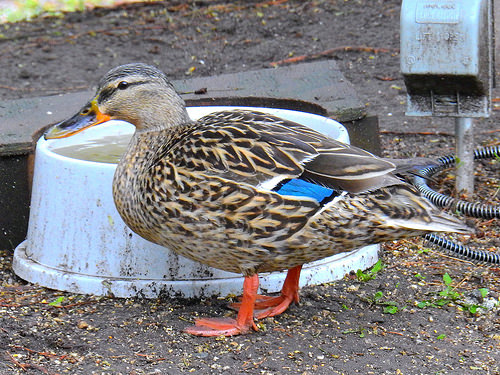<image>
Is the duck on the water? Yes. Looking at the image, I can see the duck is positioned on top of the water, with the water providing support. Where is the duck in relation to the water? Is it in front of the water? Yes. The duck is positioned in front of the water, appearing closer to the camera viewpoint. 